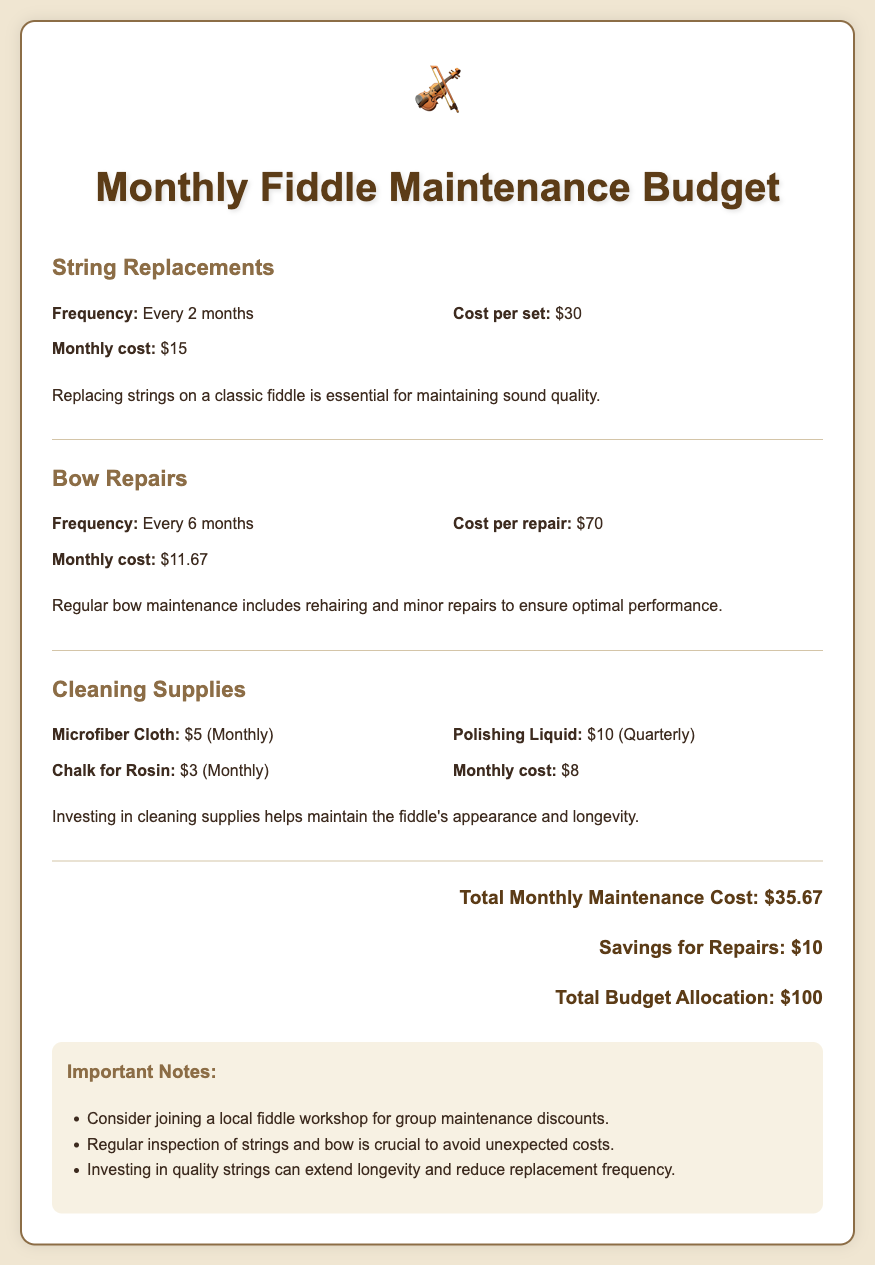What is the monthly cost of string replacements? The monthly cost of string replacements is calculated based on the frequency and cost per set, which is $15.
Answer: $15 How often are bow repairs needed? The frequency of bow repairs is provided, indicating they are required every 6 months.
Answer: Every 6 months What is the cost per repair for bow maintenance? The document specifies that each bow repair costs $70.
Answer: $70 What is the total monthly maintenance cost? The total monthly maintenance cost is given as the sum of all costs, which is $35.67.
Answer: $35.67 What are the monthly costs for cleaning supplies? The document mentions specific costs for cleaning supplies, totaling $8 monthly.
Answer: $8 How much is set aside for repairs savings? The budget allocates savings specifically for repairs, which is $10.
Answer: $10 What is the total budget allocation? The document states that the total budget allocation is $100.
Answer: $100 What should you consider joining for possible discounts? The document suggests considering a local fiddle workshop for group maintenance discounts.
Answer: Local fiddle workshop How often should you clean your fiddle? The cleaning supplies that need monthly replenishment imply a need for regular upkeep, however, frequency isn't explicitly stated.
Answer: Monthly What is the importance of investing in quality strings? The document notes that investing in quality strings can extend longevity and reduce replacement frequency.
Answer: Extend longevity 